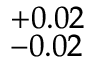Convert formula to latex. <formula><loc_0><loc_0><loc_500><loc_500>^ { + 0 . 0 2 } _ { - 0 . 0 2 }</formula> 